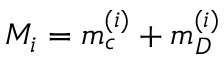<formula> <loc_0><loc_0><loc_500><loc_500>M _ { i } = m _ { c } ^ { ( i ) } + m _ { D } ^ { ( i ) }</formula> 